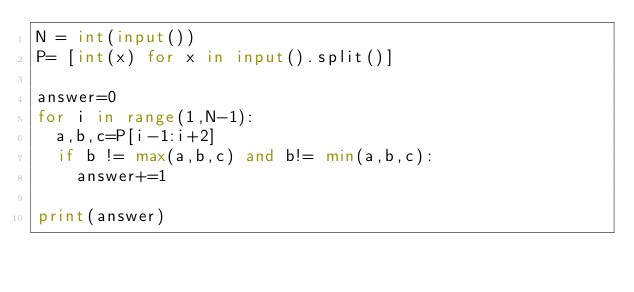Convert code to text. <code><loc_0><loc_0><loc_500><loc_500><_Python_>N = int(input())
P= [int(x) for x in input().split()]

answer=0
for i in range(1,N-1):
  a,b,c=P[i-1:i+2]
  if b != max(a,b,c) and b!= min(a,b,c):
    answer+=1

print(answer)
</code> 